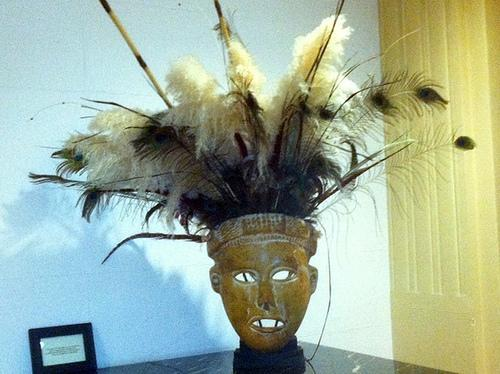Explain the relationship between the mask and its surrounding objects. The mask is the main subject of the image, and it is placed on a black stand, with a plant behind it. There is also a black framed picture and text beside it, a shadow on the wall, and nearby, a wooden door. In a quick summary, tell me about the objects in the image. The image features a weird-looking mask with a feathered headdress, a black stand, a bouquet of feathers, a framed picture and text, a plant, and a wooden door. Identify the annotated features of the mask. The mask features a face, eyes, a nose, a mouth, ears, and things coming out of the headdress. Can you count the number of eyes mentioned in the annotations? There are a total of 8 annotated eyes in the image, including eyes from the mask and sculpture. Describe the color and key features of the statue in the image. The statue is brown, and the key features of the statue include its face, eyes, nose, mouth, ears, and the black stand it is placed on. Are there any objects in the image that might help describe the sentiment of the image? The weird-looking mask, the feathered headdress, and the sculpture of a face contribute to the overall sentiment of the image, which could evoke feelings of intrigue or mystery. What kind of mask is seen in the image? A brown mask with a feathered headdress and a big bouquet of black and white feathers is the main subject in the image. What are the prominent colors seen in the image? Brown, black, white, and yellow are the prominent colors observed in the image. Does the image contain any text? If so, describe it. Yes, there are words in the picture and some text in a black framed sign. What are the key elements of the image that suggest it's an interior space? A white wall, a wooden door, a black marble countertop, a plant, and a yellow part of a wall suggest it's an interior space. Can you spot the blue bicycle leaning against the white wall? The tires need air, and it looks like it's been left there for a while. No, it's not mentioned in the image. What do the eyes on the mask look like? two eye holds in the face of a mask What type of object is found at coordinates X:226 Y:344? the statue stand What object is found at X:198 Y:211? a sculpture of a face Choose the correct statement about feathers: b) There are no feathers in the image What is the material of the door? wood What is the size and color of the eye on the mask? white, covering X:270 Y:266 Width:40 Height:40 What kind of emotion does the mask convey? weird looking What is the primary color of the statue? brown What color is the door knob? dark What is the color of the wall in the background? white Describe the central object in the image. a brown mask with a feathered headdress What material is the counter top made of? black marble What color is the picture frame? black What object is behind the mask? a plant Contrast the nose and mouth of the sculpture. the nose is smaller than the mouth What is the primary purpose of the black frame in the image? to hold some text What is on top of the table? the mask on a black stand Identify the object placed at the left-top corner of the image. a sculpture with peacock feathers on top 